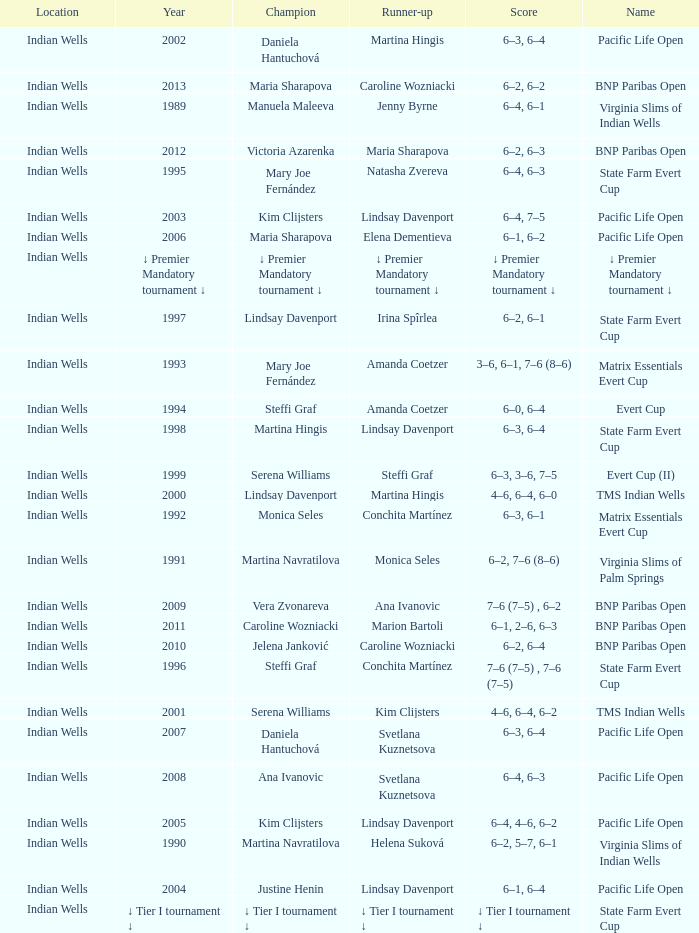Who was runner-up in the 2006 Pacific Life Open? Elena Dementieva. 